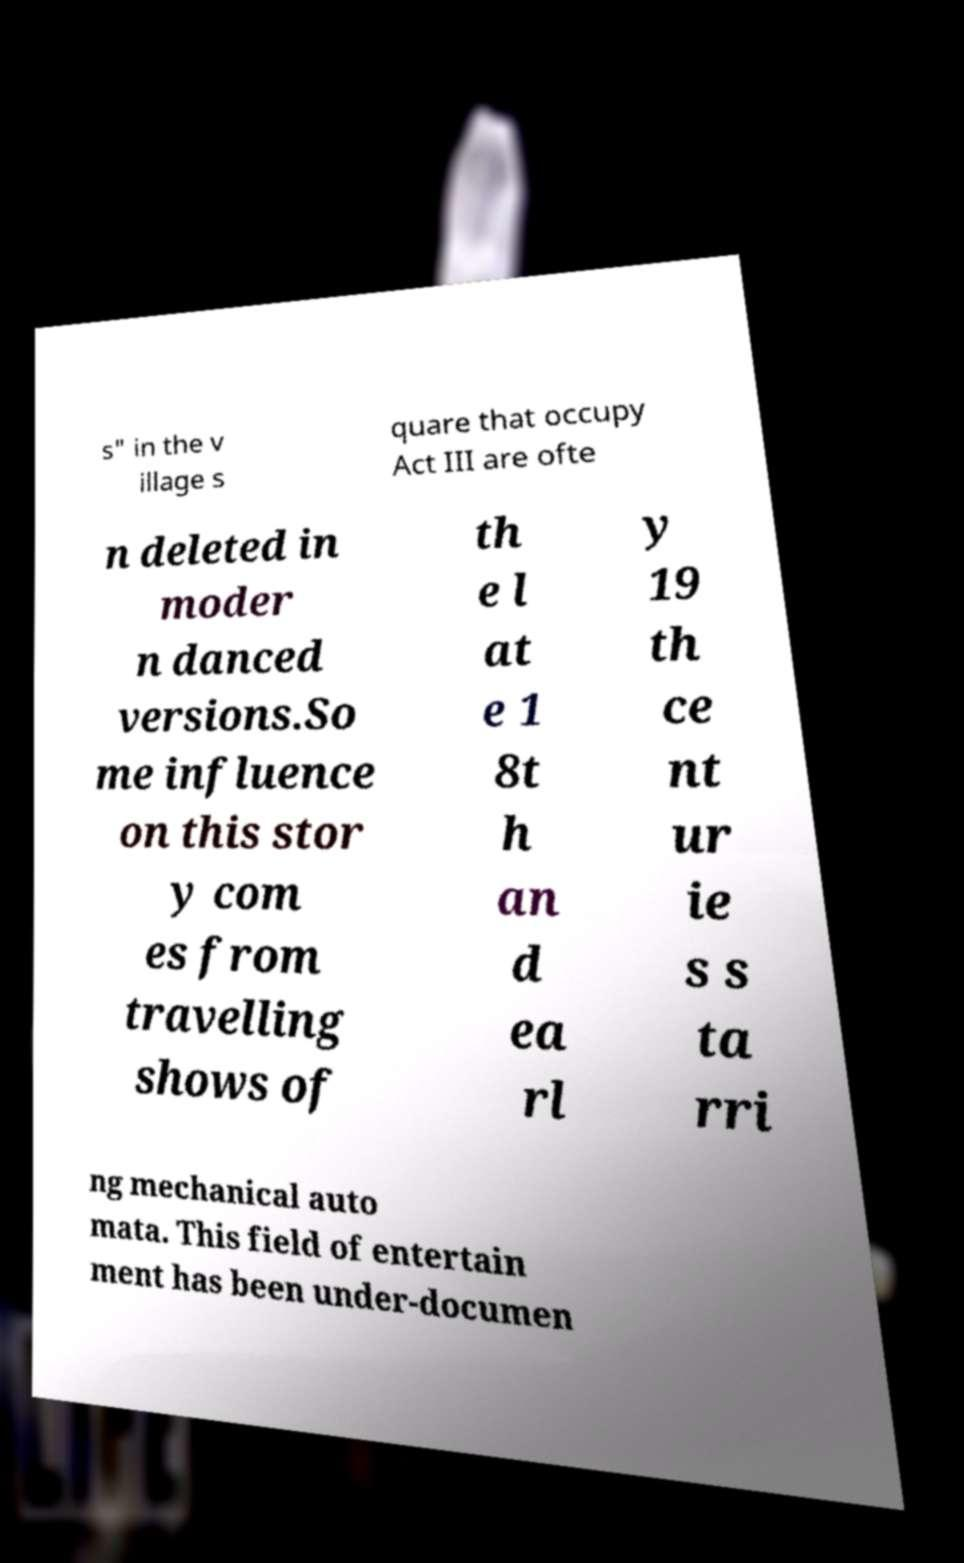Can you read and provide the text displayed in the image?This photo seems to have some interesting text. Can you extract and type it out for me? s" in the v illage s quare that occupy Act III are ofte n deleted in moder n danced versions.So me influence on this stor y com es from travelling shows of th e l at e 1 8t h an d ea rl y 19 th ce nt ur ie s s ta rri ng mechanical auto mata. This field of entertain ment has been under-documen 